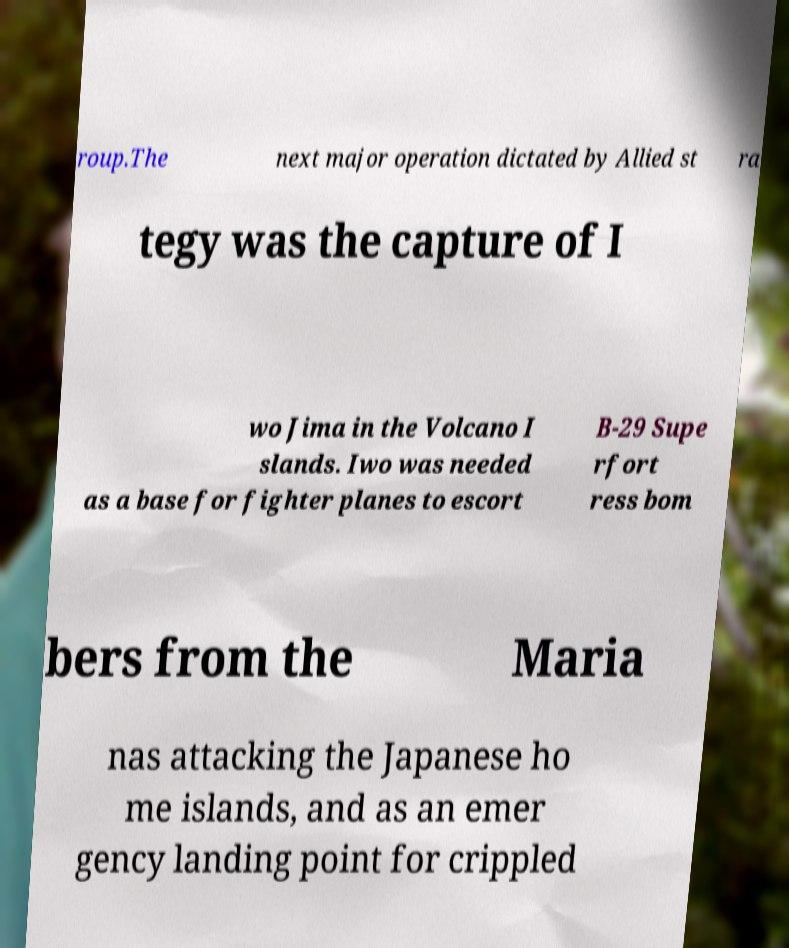Please identify and transcribe the text found in this image. roup.The next major operation dictated by Allied st ra tegy was the capture of I wo Jima in the Volcano I slands. Iwo was needed as a base for fighter planes to escort B-29 Supe rfort ress bom bers from the Maria nas attacking the Japanese ho me islands, and as an emer gency landing point for crippled 